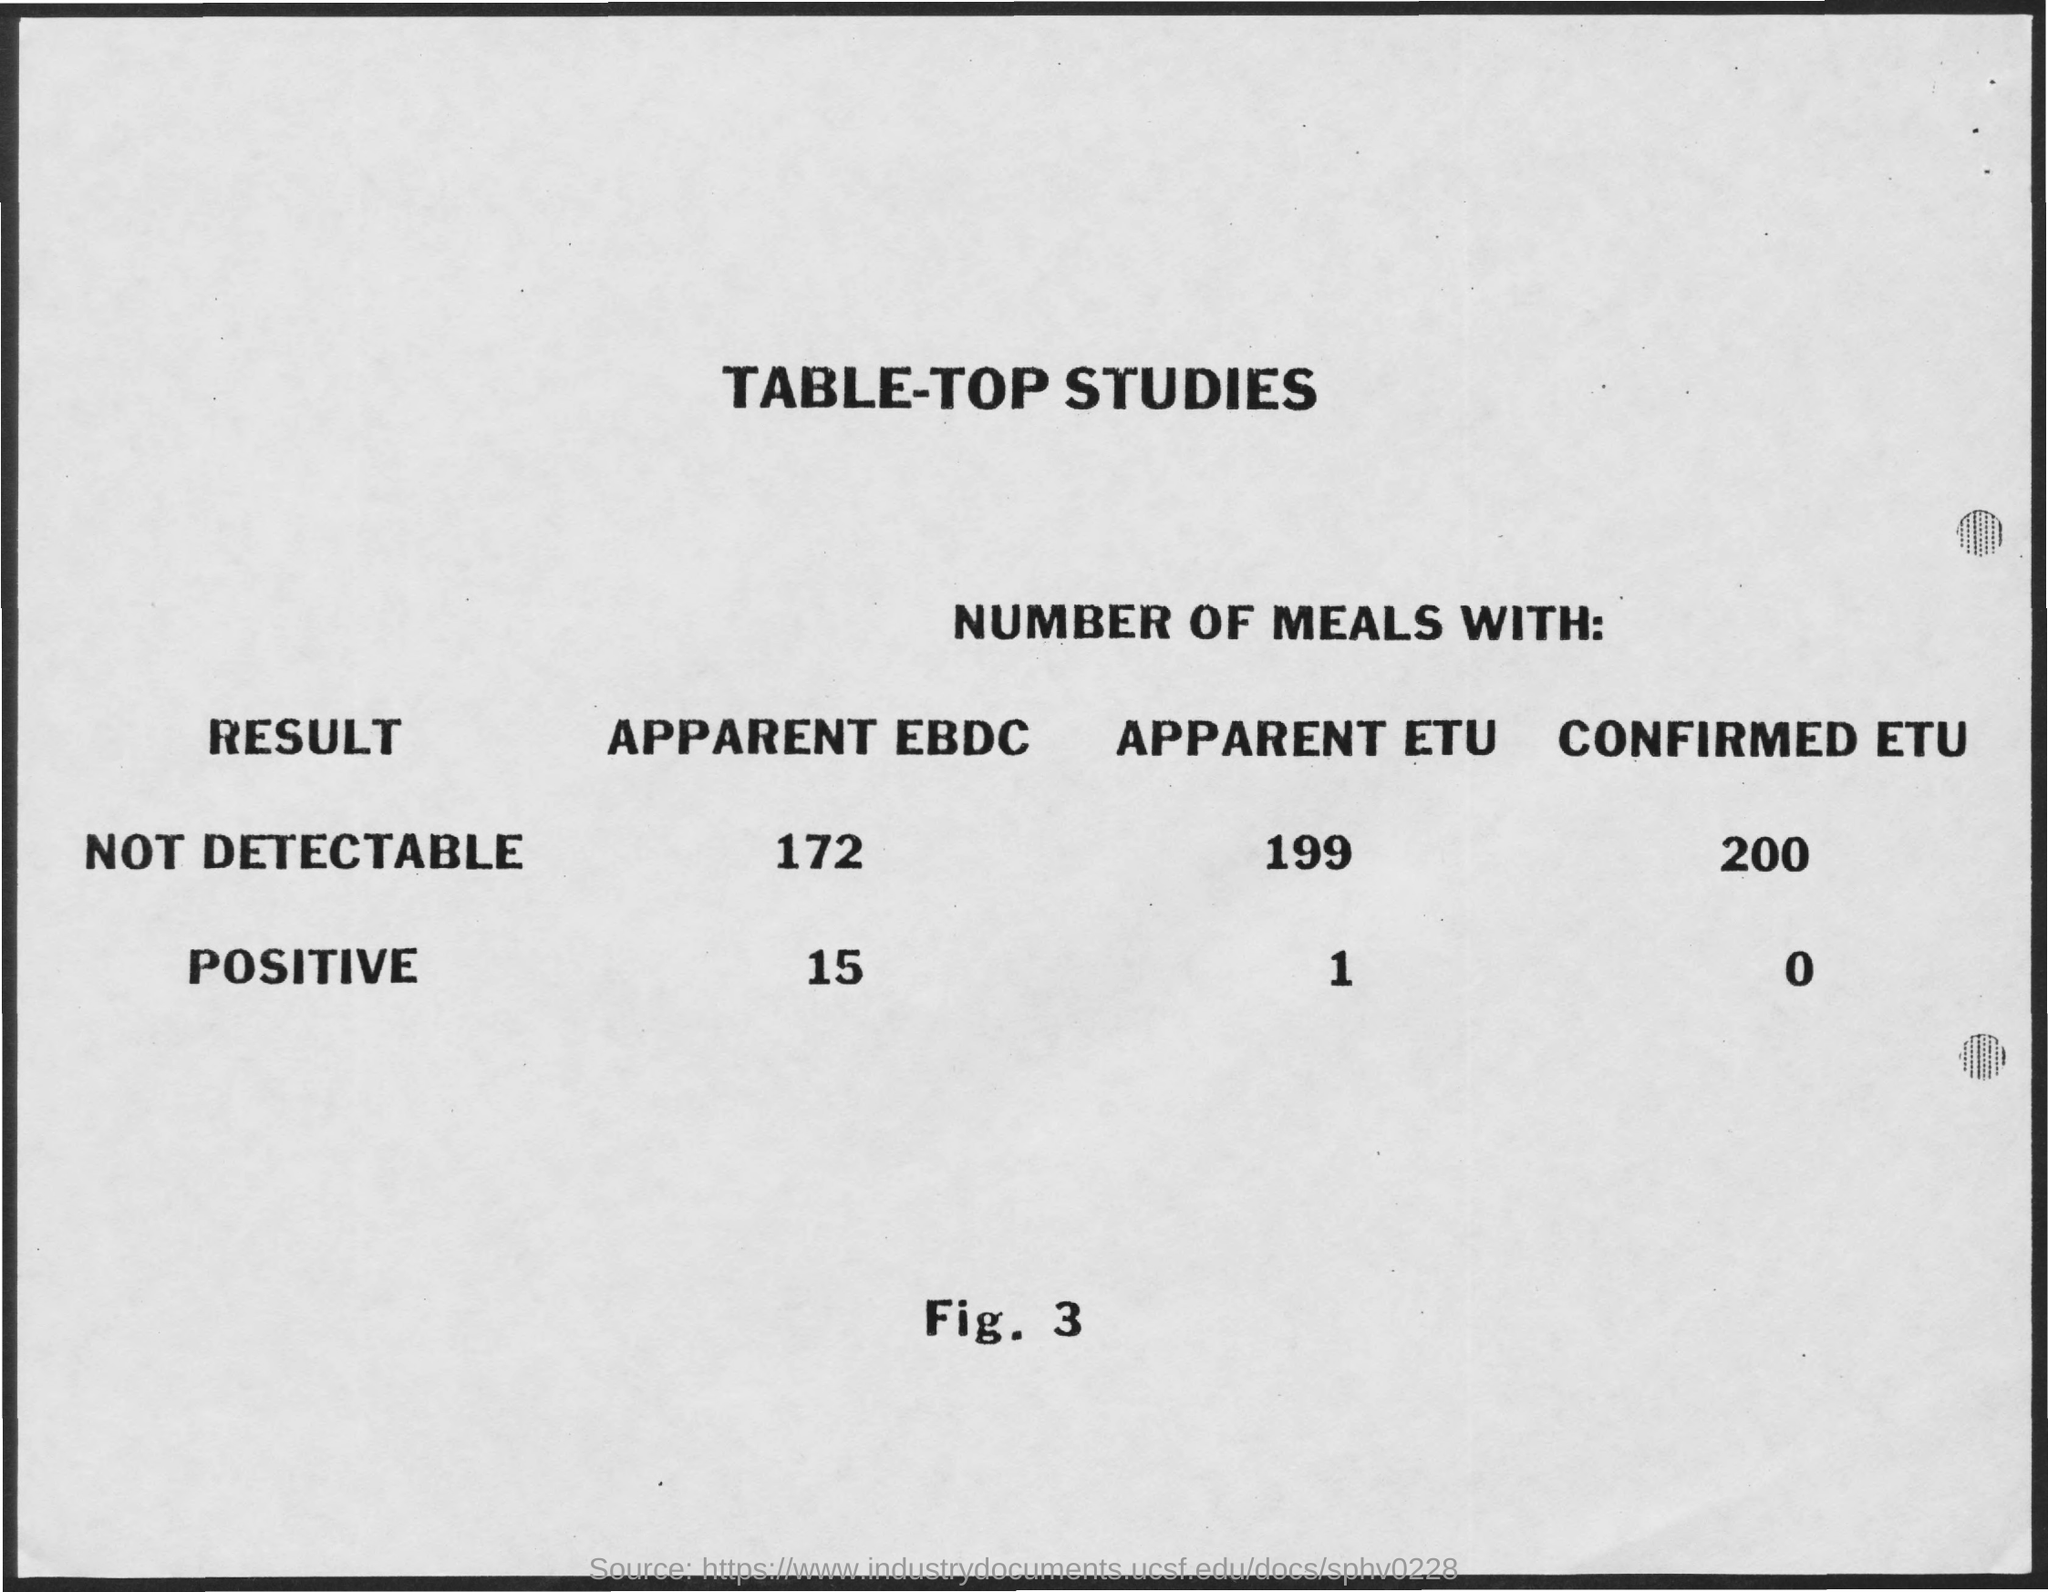What is the result of not detectable apparent ebdc ?
Your response must be concise. 172. What is the result of not detectable apparent etu ?
Provide a succinct answer. 199. 